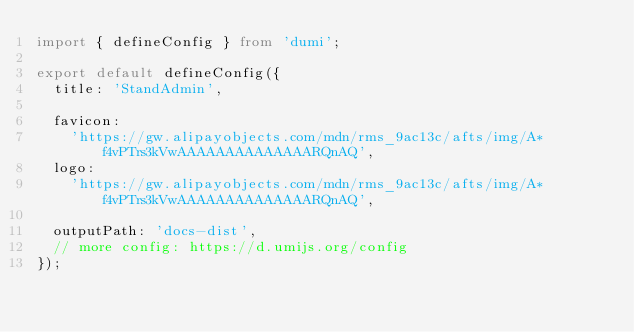Convert code to text. <code><loc_0><loc_0><loc_500><loc_500><_TypeScript_>import { defineConfig } from 'dumi';

export default defineConfig({
  title: 'StandAdmin',

  favicon:
    'https://gw.alipayobjects.com/mdn/rms_9ac13c/afts/img/A*f4vPTrs3kVwAAAAAAAAAAAAAARQnAQ',
  logo:
    'https://gw.alipayobjects.com/mdn/rms_9ac13c/afts/img/A*f4vPTrs3kVwAAAAAAAAAAAAAARQnAQ',

  outputPath: 'docs-dist',
  // more config: https://d.umijs.org/config
});
</code> 